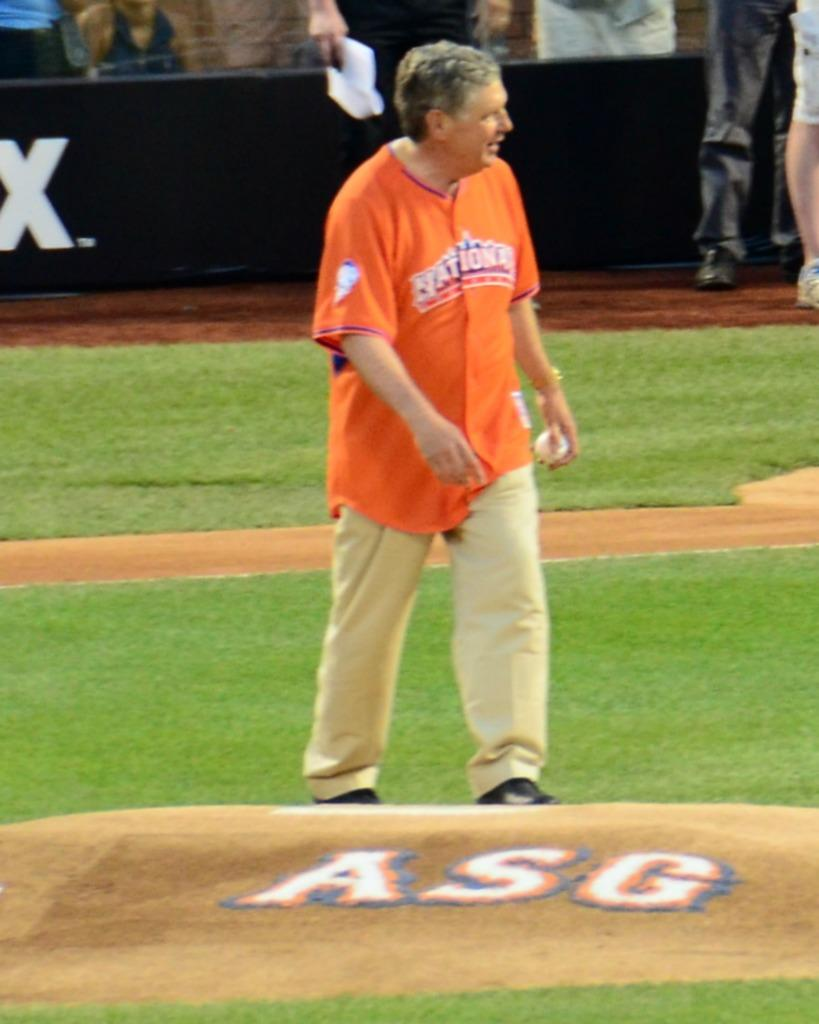Provide a one-sentence caption for the provided image. a man that has a shirt on next to an ASG logo. 